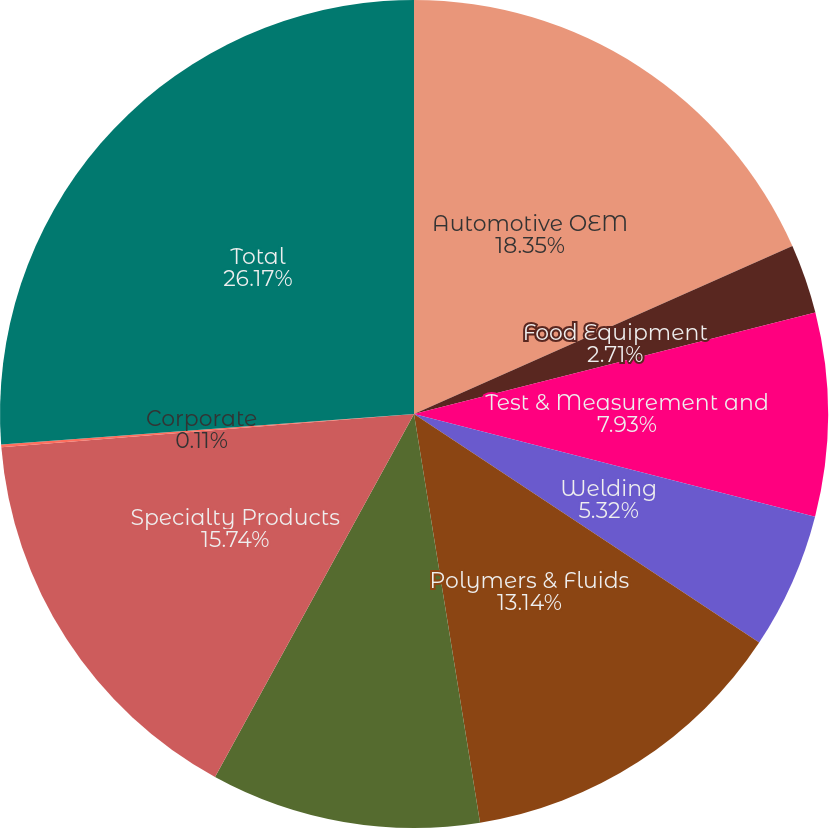<chart> <loc_0><loc_0><loc_500><loc_500><pie_chart><fcel>Automotive OEM<fcel>Food Equipment<fcel>Test & Measurement and<fcel>Welding<fcel>Polymers & Fluids<fcel>Construction Products<fcel>Specialty Products<fcel>Corporate<fcel>Total<nl><fcel>18.35%<fcel>2.71%<fcel>7.93%<fcel>5.32%<fcel>13.14%<fcel>10.53%<fcel>15.74%<fcel>0.11%<fcel>26.17%<nl></chart> 